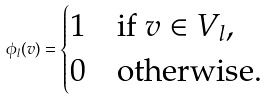<formula> <loc_0><loc_0><loc_500><loc_500>\phi _ { l } ( v ) = \begin{cases} 1 & \text {if } v \in V _ { l } , \\ 0 & \text {otherwise.} \end{cases}</formula> 